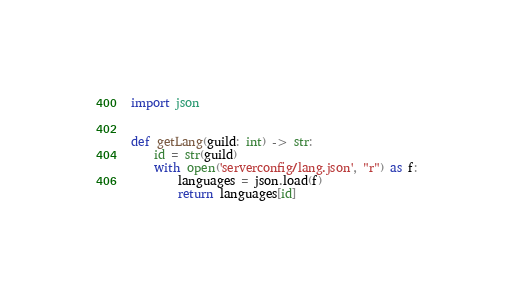<code> <loc_0><loc_0><loc_500><loc_500><_Python_>import json


def getLang(guild: int) -> str:
    id = str(guild)
    with open('serverconfig/lang.json', "r") as f:
        languages = json.load(f)
        return languages[id]
</code> 